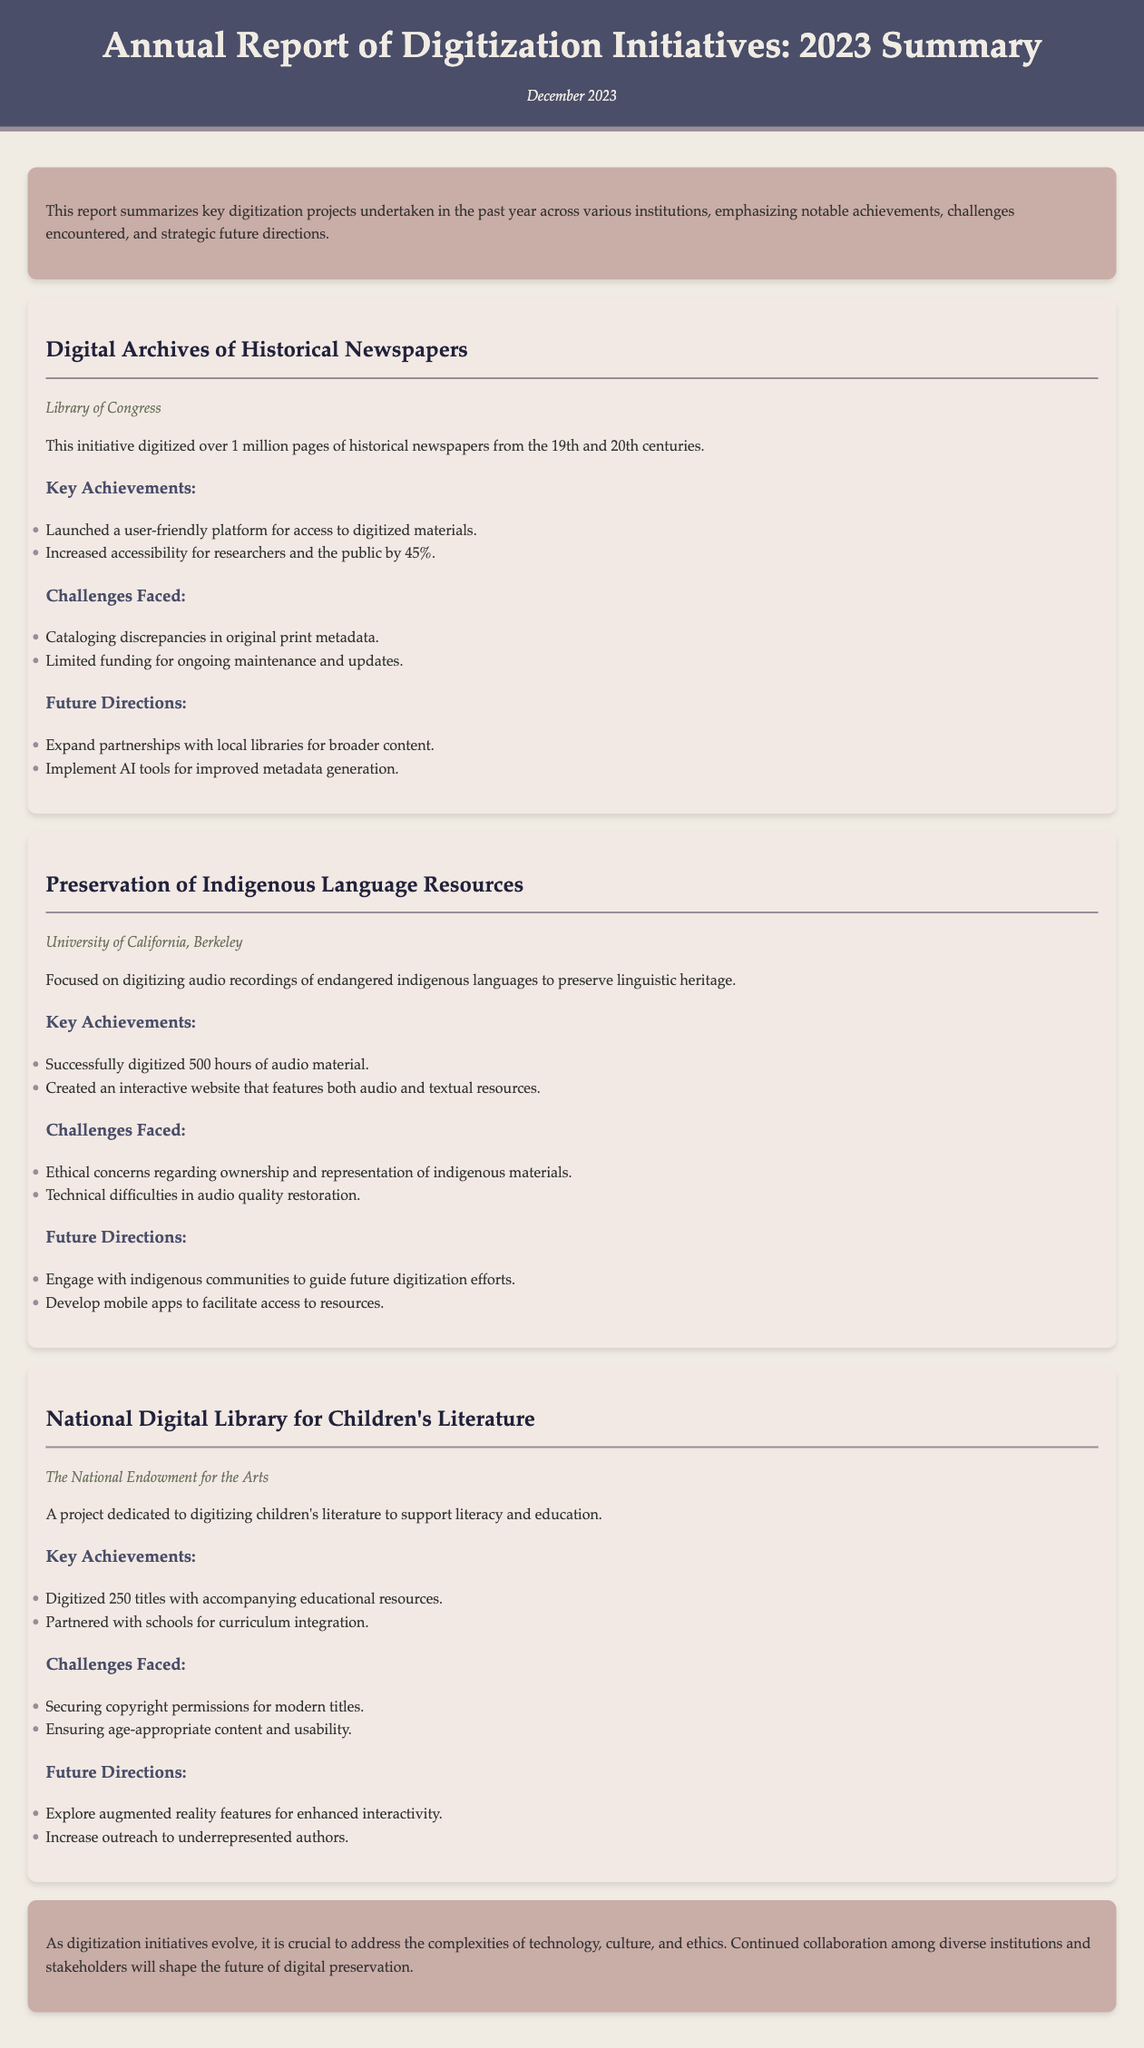What is the title of the report? The title of the report is presented at the top of the document.
Answer: Annual Report of Digitization Initiatives: 2023 Summary Which institution digitized over 1 million pages of newspapers? The institution that undertook this project is mentioned in the first project section.
Answer: Library of Congress How many hours of audio material were successfully digitized for indigenous languages? This information is provided in the project details for the indigenous language resources.
Answer: 500 hours What was a key achievement of the National Digital Library for Children's Literature? The relevant achievement is stated in the project section focused on children’s literature.
Answer: Digitized 250 titles What ethical concern was mentioned regarding the preservation of indigenous language resources? This concern is specifically outlined in the challenges faced by the respective project.
Answer: Ownership and representation What future direction involves working with local libraries? The future direction is explicitly listed in the Digital Archives of Historical Newspapers project.
Answer: Expand partnerships with local libraries What is a common challenge faced across the digitization initiatives according to the report? The report highlights repeated themes across different projects, particularly in the challenges section.
Answer: Limited funding What is suggested for enhancing interactivity in children's literature? This suggestion is given in the future directions of the National Digital Library for Children's Literature.
Answer: Augmented reality features 